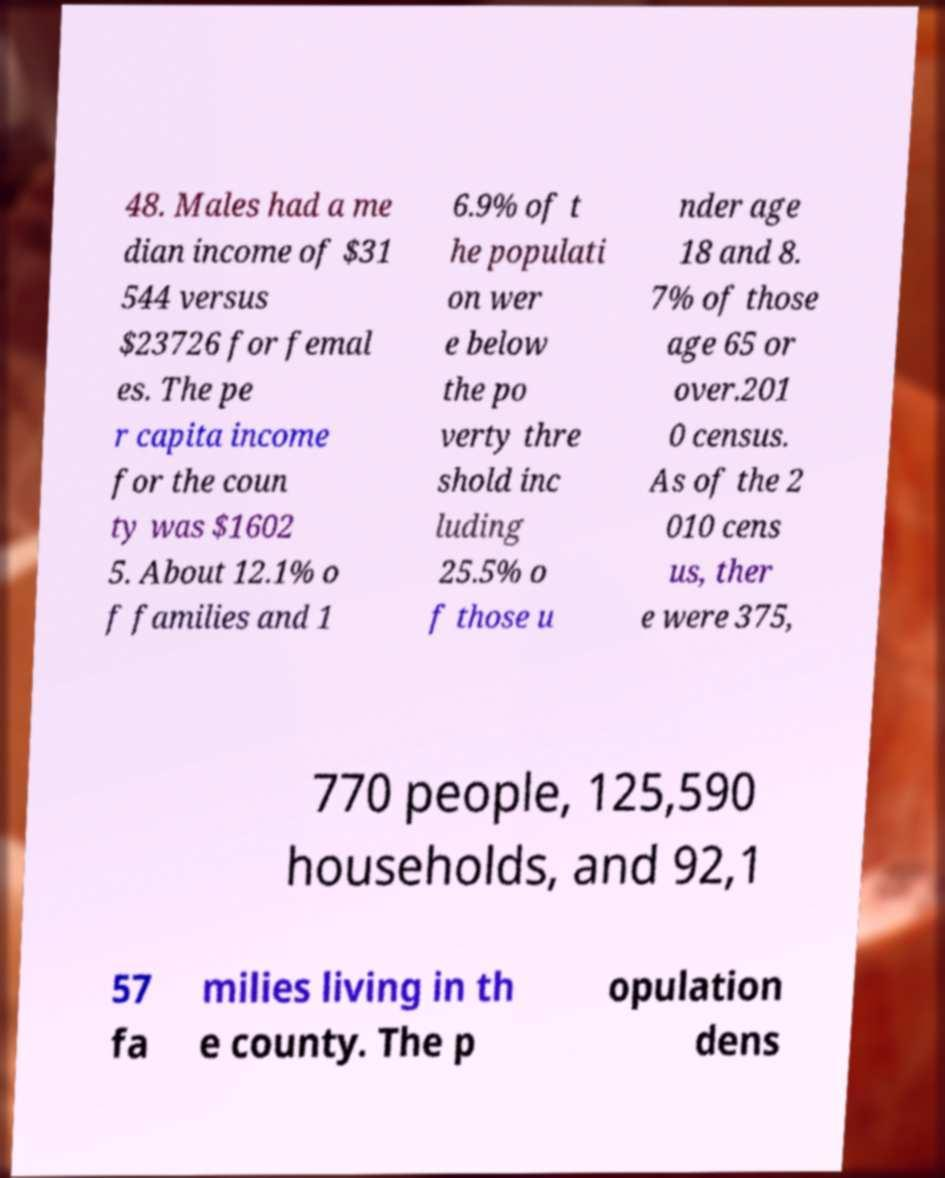Please read and relay the text visible in this image. What does it say? 48. Males had a me dian income of $31 544 versus $23726 for femal es. The pe r capita income for the coun ty was $1602 5. About 12.1% o f families and 1 6.9% of t he populati on wer e below the po verty thre shold inc luding 25.5% o f those u nder age 18 and 8. 7% of those age 65 or over.201 0 census. As of the 2 010 cens us, ther e were 375, 770 people, 125,590 households, and 92,1 57 fa milies living in th e county. The p opulation dens 